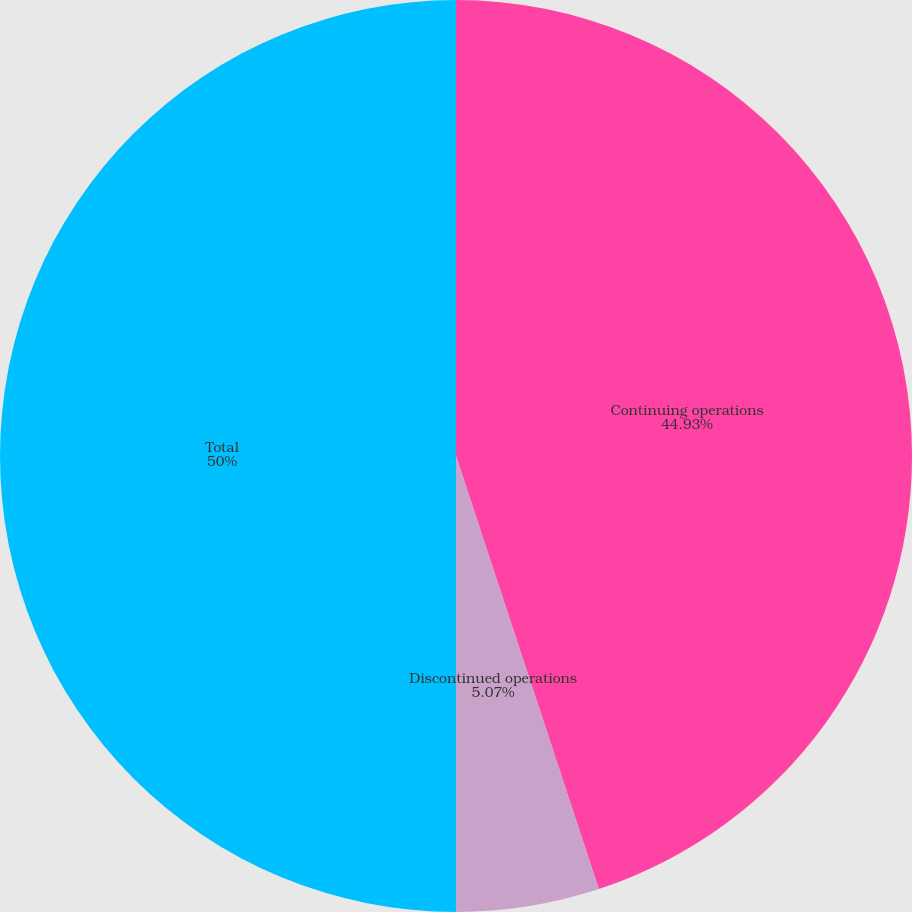<chart> <loc_0><loc_0><loc_500><loc_500><pie_chart><fcel>Continuing operations<fcel>Discontinued operations<fcel>Total<nl><fcel>44.93%<fcel>5.07%<fcel>50.0%<nl></chart> 